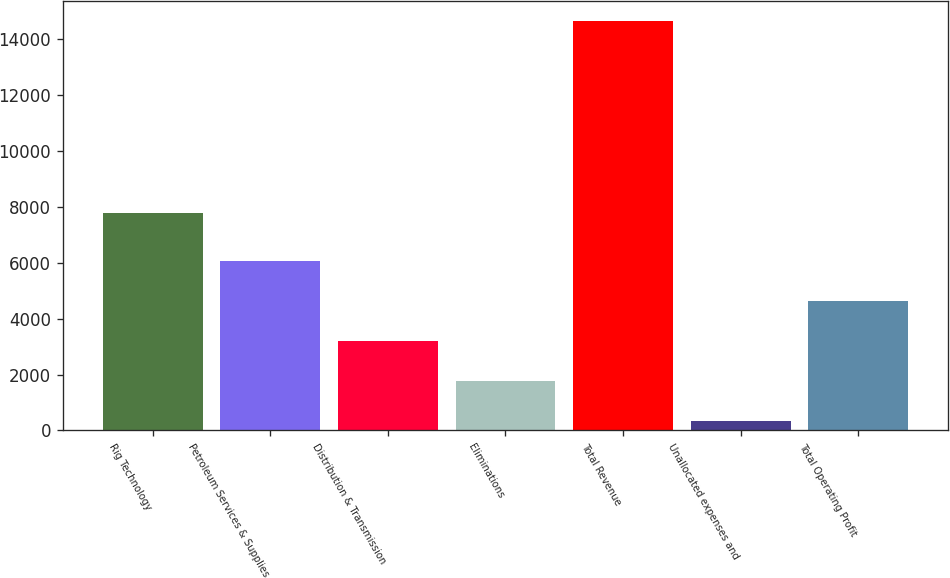Convert chart. <chart><loc_0><loc_0><loc_500><loc_500><bar_chart><fcel>Rig Technology<fcel>Petroleum Services & Supplies<fcel>Distribution & Transmission<fcel>Eliminations<fcel>Total Revenue<fcel>Unallocated expenses and<fcel>Total Operating Profit<nl><fcel>7788<fcel>6057<fcel>3190<fcel>1756.5<fcel>14658<fcel>323<fcel>4623.5<nl></chart> 